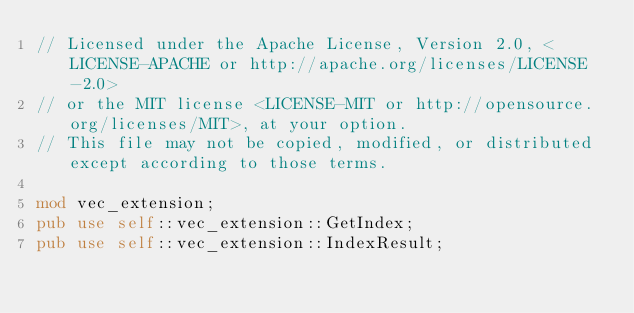<code> <loc_0><loc_0><loc_500><loc_500><_Rust_>// Licensed under the Apache License, Version 2.0, <LICENSE-APACHE or http://apache.org/licenses/LICENSE-2.0>
// or the MIT license <LICENSE-MIT or http://opensource.org/licenses/MIT>, at your option.
// This file may not be copied, modified, or distributed except according to those terms.

mod vec_extension;
pub use self::vec_extension::GetIndex;
pub use self::vec_extension::IndexResult;</code> 